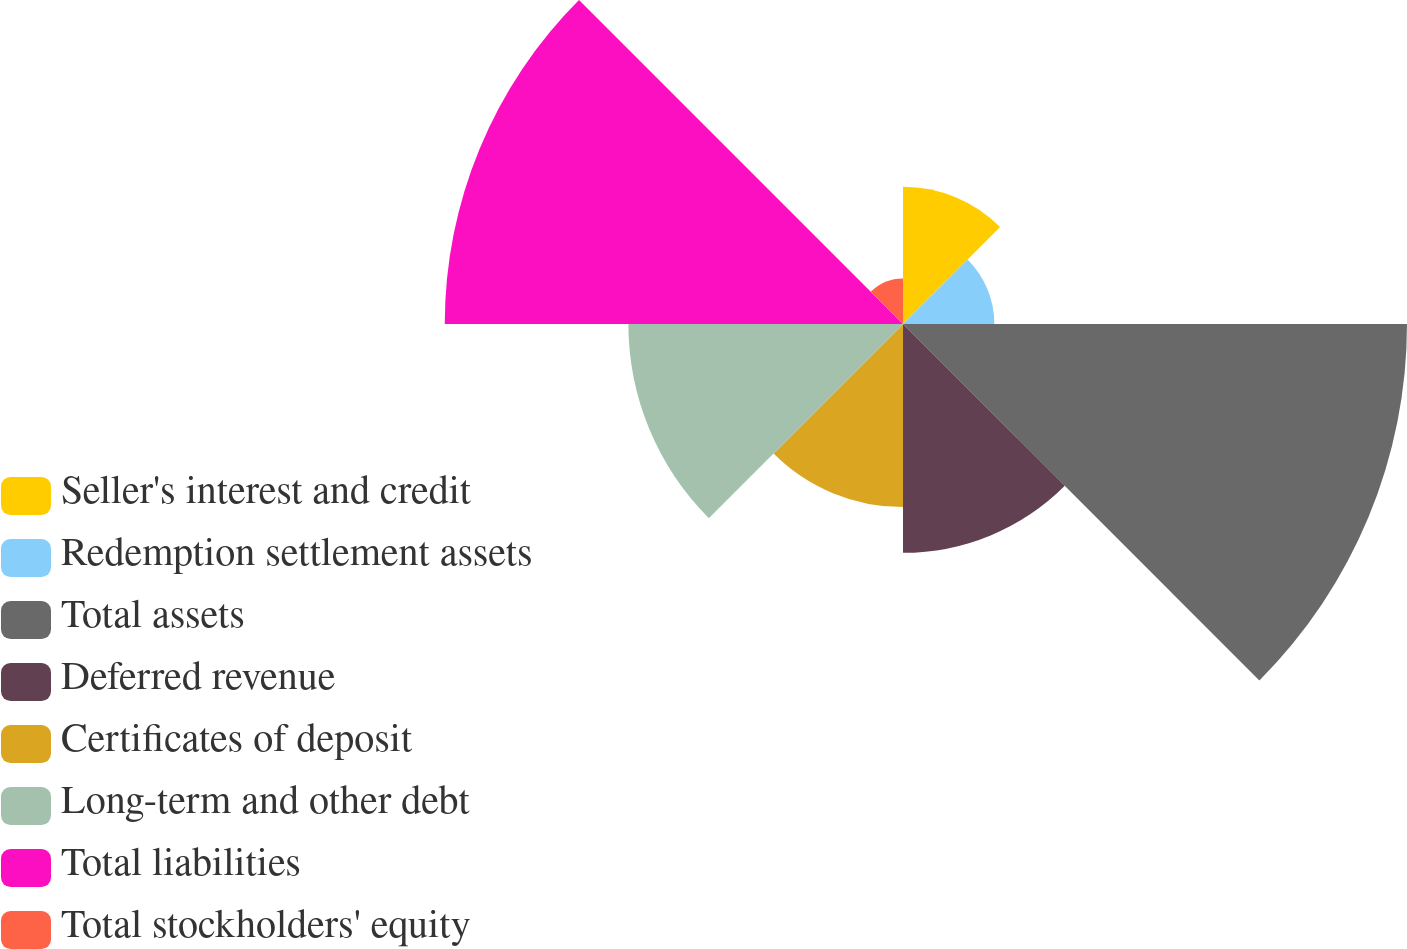Convert chart. <chart><loc_0><loc_0><loc_500><loc_500><pie_chart><fcel>Seller's interest and credit<fcel>Redemption settlement assets<fcel>Total assets<fcel>Deferred revenue<fcel>Certificates of deposit<fcel>Long-term and other debt<fcel>Total liabilities<fcel>Total stockholders' equity<nl><fcel>7.14%<fcel>4.75%<fcel>26.21%<fcel>11.9%<fcel>9.52%<fcel>14.28%<fcel>23.83%<fcel>2.37%<nl></chart> 